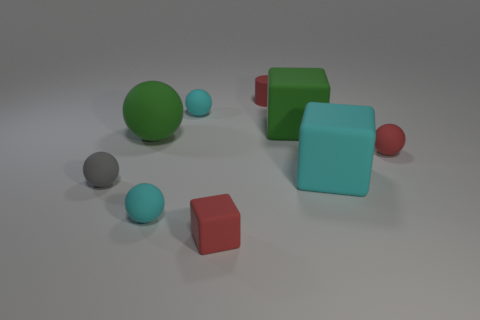Subtract all gray spheres. How many spheres are left? 4 Subtract all purple spheres. Subtract all brown blocks. How many spheres are left? 5 Add 1 red matte objects. How many objects exist? 10 Subtract all cylinders. How many objects are left? 8 Add 9 tiny red rubber blocks. How many tiny red rubber blocks are left? 10 Add 6 gray rubber objects. How many gray rubber objects exist? 7 Subtract 1 red balls. How many objects are left? 8 Subtract all red rubber cylinders. Subtract all gray balls. How many objects are left? 7 